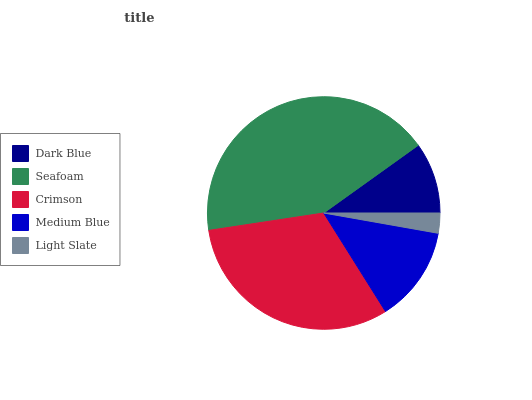Is Light Slate the minimum?
Answer yes or no. Yes. Is Seafoam the maximum?
Answer yes or no. Yes. Is Crimson the minimum?
Answer yes or no. No. Is Crimson the maximum?
Answer yes or no. No. Is Seafoam greater than Crimson?
Answer yes or no. Yes. Is Crimson less than Seafoam?
Answer yes or no. Yes. Is Crimson greater than Seafoam?
Answer yes or no. No. Is Seafoam less than Crimson?
Answer yes or no. No. Is Medium Blue the high median?
Answer yes or no. Yes. Is Medium Blue the low median?
Answer yes or no. Yes. Is Light Slate the high median?
Answer yes or no. No. Is Light Slate the low median?
Answer yes or no. No. 